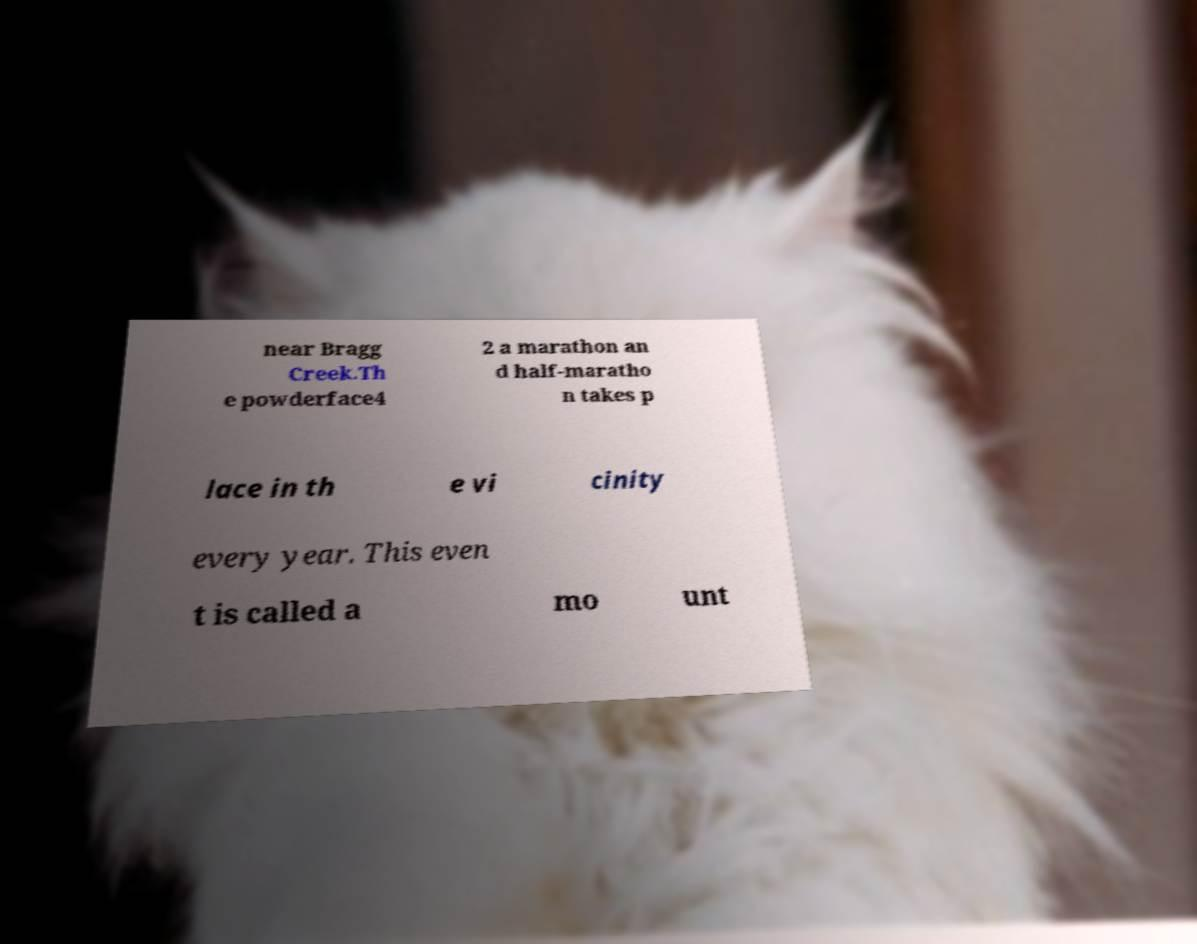Can you read and provide the text displayed in the image?This photo seems to have some interesting text. Can you extract and type it out for me? near Bragg Creek.Th e powderface4 2 a marathon an d half-maratho n takes p lace in th e vi cinity every year. This even t is called a mo unt 